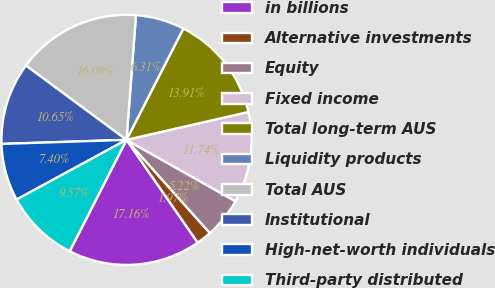<chart> <loc_0><loc_0><loc_500><loc_500><pie_chart><fcel>in billions<fcel>Alternative investments<fcel>Equity<fcel>Fixed income<fcel>Total long-term AUS<fcel>Liquidity products<fcel>Total AUS<fcel>Institutional<fcel>High-net-worth individuals<fcel>Third-party distributed<nl><fcel>17.16%<fcel>1.97%<fcel>5.22%<fcel>11.74%<fcel>13.91%<fcel>6.31%<fcel>16.08%<fcel>10.65%<fcel>7.4%<fcel>9.57%<nl></chart> 